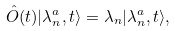Convert formula to latex. <formula><loc_0><loc_0><loc_500><loc_500>\hat { O } ( t ) | \lambda _ { n } ^ { a } , t \rangle = \lambda _ { n } | \lambda _ { n } ^ { a } , t \rangle ,</formula> 